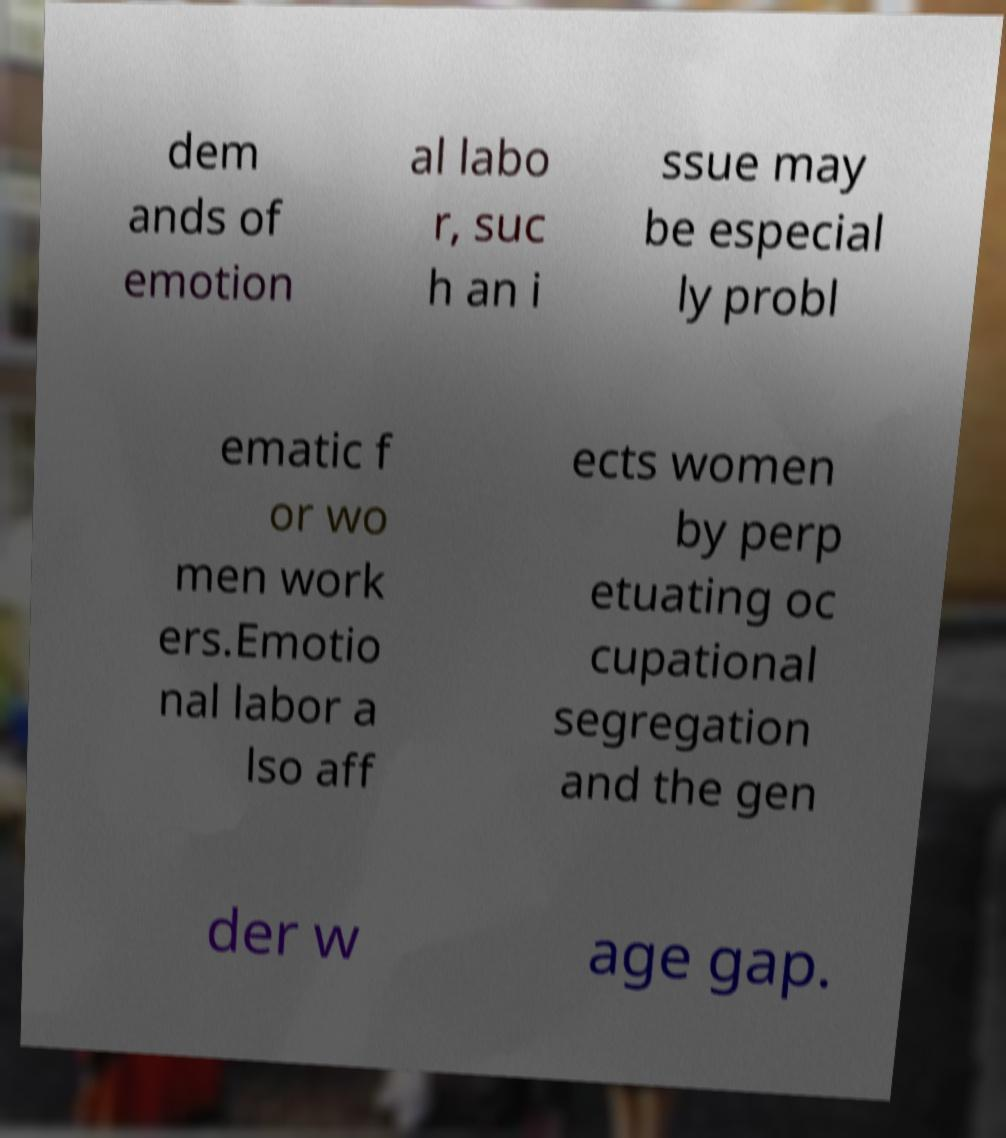Can you accurately transcribe the text from the provided image for me? dem ands of emotion al labo r, suc h an i ssue may be especial ly probl ematic f or wo men work ers.Emotio nal labor a lso aff ects women by perp etuating oc cupational segregation and the gen der w age gap. 